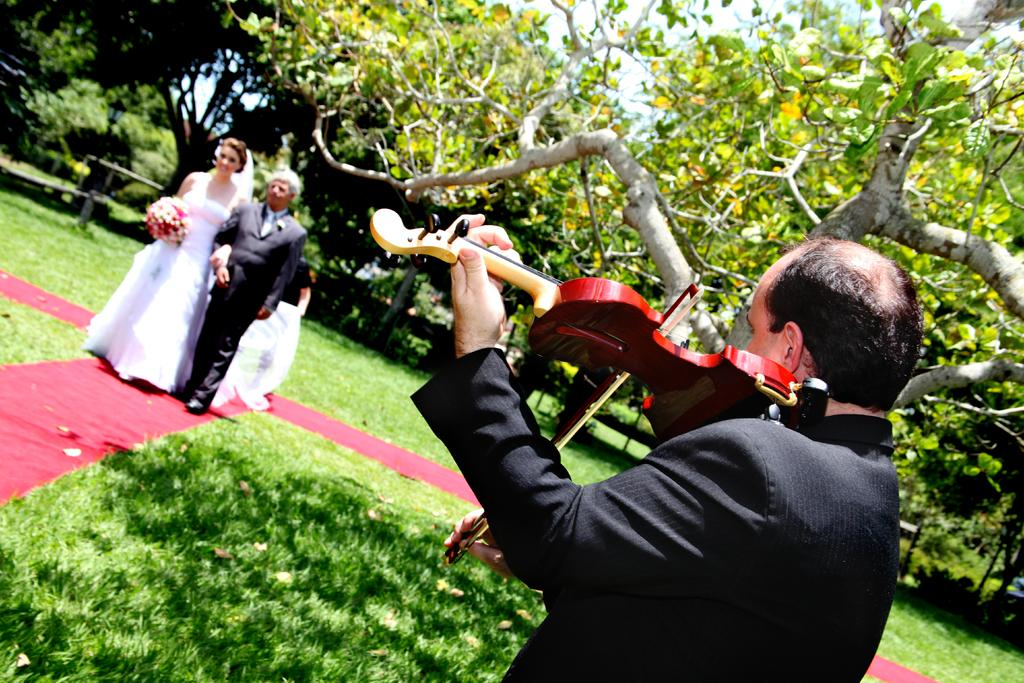What type of vegetation is present in the image? There is grass in the image. What is the person on the right side of the image doing? The person is holding a musical instrument. What can be seen on the left side of the image? There is a couple on the left side of the image. What is visible in the background of the image? There are trees in the background of the image. Can you tell me how many chickens are present in the image? There are no chickens present in the image. What type of thrill can be experienced by the couple in the image? The image does not provide information about any thrilling experiences; it simply shows a couple on the left side. 